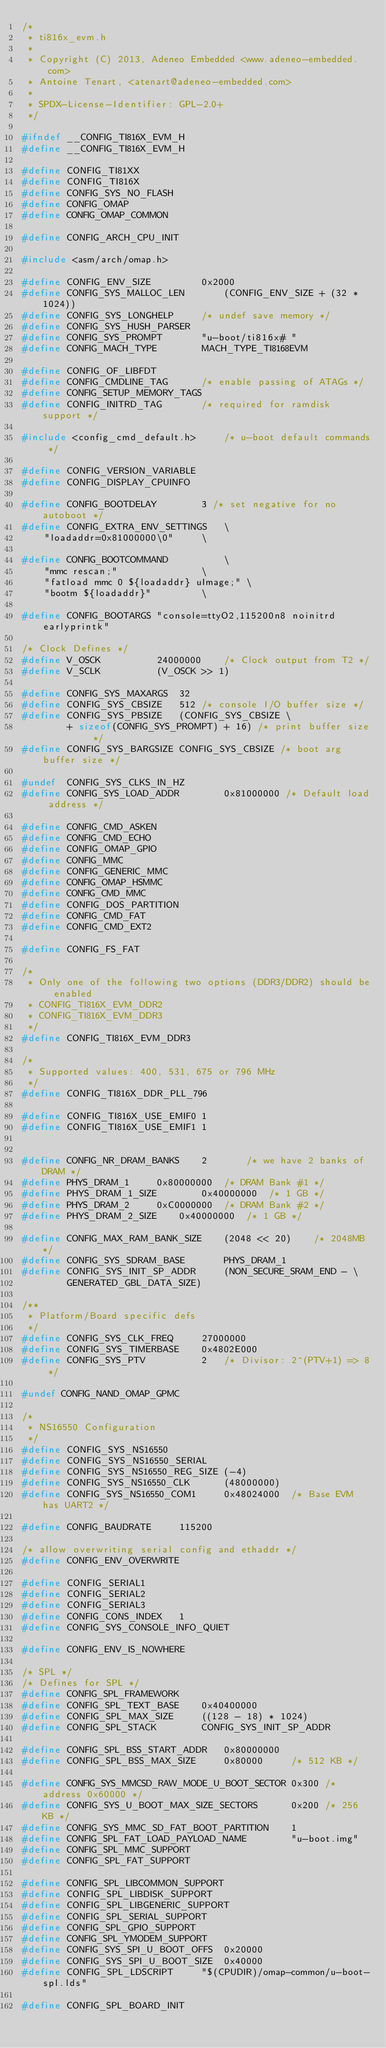Convert code to text. <code><loc_0><loc_0><loc_500><loc_500><_C_>/*
 * ti816x_evm.h
 *
 * Copyright (C) 2013, Adeneo Embedded <www.adeneo-embedded.com>
 * Antoine Tenart, <atenart@adeneo-embedded.com>
 *
 * SPDX-License-Identifier:	GPL-2.0+
 */

#ifndef __CONFIG_TI816X_EVM_H
#define __CONFIG_TI816X_EVM_H

#define CONFIG_TI81XX
#define CONFIG_TI816X
#define CONFIG_SYS_NO_FLASH
#define CONFIG_OMAP
#define CONFIG_OMAP_COMMON

#define CONFIG_ARCH_CPU_INIT

#include <asm/arch/omap.h>

#define CONFIG_ENV_SIZE			0x2000
#define CONFIG_SYS_MALLOC_LEN		(CONFIG_ENV_SIZE + (32 * 1024))
#define CONFIG_SYS_LONGHELP		/* undef save memory */
#define CONFIG_SYS_HUSH_PARSER
#define CONFIG_SYS_PROMPT		"u-boot/ti816x# "
#define CONFIG_MACH_TYPE		MACH_TYPE_TI8168EVM

#define CONFIG_OF_LIBFDT
#define CONFIG_CMDLINE_TAG		/* enable passing of ATAGs */
#define CONFIG_SETUP_MEMORY_TAGS
#define CONFIG_INITRD_TAG		/* required for ramdisk support */

#include <config_cmd_default.h>		/* u-boot default commands */

#define CONFIG_VERSION_VARIABLE
#define CONFIG_DISPLAY_CPUINFO

#define CONFIG_BOOTDELAY		3 /* set negative for no autoboot */
#define CONFIG_EXTRA_ENV_SETTINGS	\
	"loadaddr=0x81000000\0"		\

#define CONFIG_BOOTCOMMAND			\
	"mmc rescan;"				\
	"fatload mmc 0 ${loadaddr} uImage;"	\
	"bootm ${loadaddr}"			\

#define CONFIG_BOOTARGS	"console=ttyO2,115200n8 noinitrd earlyprintk"

/* Clock Defines */
#define V_OSCK          24000000    /* Clock output from T2 */
#define V_SCLK          (V_OSCK >> 1)

#define CONFIG_SYS_MAXARGS	32
#define CONFIG_SYS_CBSIZE	512 /* console I/O buffer size */
#define CONFIG_SYS_PBSIZE	(CONFIG_SYS_CBSIZE \
		+ sizeof(CONFIG_SYS_PROMPT) + 16) /* print buffer size */
#define CONFIG_SYS_BARGSIZE	CONFIG_SYS_CBSIZE /* boot arg buffer size */

#undef  CONFIG_SYS_CLKS_IN_HZ
#define CONFIG_SYS_LOAD_ADDR		0x81000000 /* Default load address */

#define CONFIG_CMD_ASKEN
#define CONFIG_CMD_ECHO
#define CONFIG_OMAP_GPIO
#define CONFIG_MMC
#define CONFIG_GENERIC_MMC
#define CONFIG_OMAP_HSMMC
#define CONFIG_CMD_MMC
#define CONFIG_DOS_PARTITION
#define CONFIG_CMD_FAT
#define CONFIG_CMD_EXT2

#define CONFIG_FS_FAT

/*
 * Only one of the following two options (DDR3/DDR2) should be enabled
 * CONFIG_TI816X_EVM_DDR2
 * CONFIG_TI816X_EVM_DDR3
 */
#define CONFIG_TI816X_EVM_DDR3

/*
 * Supported values: 400, 531, 675 or 796 MHz
 */
#define CONFIG_TI816X_DDR_PLL_796

#define CONFIG_TI816X_USE_EMIF0	1
#define CONFIG_TI816X_USE_EMIF1	1


#define CONFIG_NR_DRAM_BANKS	2		/* we have 2 banks of DRAM */
#define PHYS_DRAM_1		0x80000000	/* DRAM Bank #1 */
#define PHYS_DRAM_1_SIZE        0x40000000	/* 1 GB */
#define PHYS_DRAM_2		0xC0000000	/* DRAM Bank #2 */
#define PHYS_DRAM_2_SIZE	0x40000000	/* 1 GB */

#define CONFIG_MAX_RAM_BANK_SIZE	(2048 << 20)	/* 2048MB */
#define CONFIG_SYS_SDRAM_BASE		PHYS_DRAM_1
#define CONFIG_SYS_INIT_SP_ADDR		(NON_SECURE_SRAM_END - \
		GENERATED_GBL_DATA_SIZE)

/**
 * Platform/Board specific defs
 */
#define CONFIG_SYS_CLK_FREQ     27000000
#define CONFIG_SYS_TIMERBASE    0x4802E000
#define CONFIG_SYS_PTV          2   /* Divisor: 2^(PTV+1) => 8 */

#undef CONFIG_NAND_OMAP_GPMC

/*
 * NS16550 Configuration
 */
#define CONFIG_SYS_NS16550
#define CONFIG_SYS_NS16550_SERIAL
#define CONFIG_SYS_NS16550_REG_SIZE (-4)
#define CONFIG_SYS_NS16550_CLK      (48000000)
#define CONFIG_SYS_NS16550_COM1     0x48024000  /* Base EVM has UART2 */

#define CONFIG_BAUDRATE     115200

/* allow overwriting serial config and ethaddr */
#define CONFIG_ENV_OVERWRITE

#define CONFIG_SERIAL1
#define CONFIG_SERIAL2
#define CONFIG_SERIAL3
#define CONFIG_CONS_INDEX	1
#define CONFIG_SYS_CONSOLE_INFO_QUIET

#define CONFIG_ENV_IS_NOWHERE

/* SPL */
/* Defines for SPL */
#define CONFIG_SPL_FRAMEWORK
#define CONFIG_SPL_TEXT_BASE    0x40400000
#define CONFIG_SPL_MAX_SIZE     ((128 - 18) * 1024)
#define CONFIG_SPL_STACK        CONFIG_SYS_INIT_SP_ADDR

#define CONFIG_SPL_BSS_START_ADDR   0x80000000
#define CONFIG_SPL_BSS_MAX_SIZE     0x80000     /* 512 KB */

#define CONFIG_SYS_MMCSD_RAW_MODE_U_BOOT_SECTOR 0x300 /* address 0x60000 */
#define CONFIG_SYS_U_BOOT_MAX_SIZE_SECTORS      0x200 /* 256 KB */
#define CONFIG_SYS_MMC_SD_FAT_BOOT_PARTITION    1
#define CONFIG_SPL_FAT_LOAD_PAYLOAD_NAME        "u-boot.img"
#define CONFIG_SPL_MMC_SUPPORT
#define CONFIG_SPL_FAT_SUPPORT

#define CONFIG_SPL_LIBCOMMON_SUPPORT
#define CONFIG_SPL_LIBDISK_SUPPORT
#define CONFIG_SPL_LIBGENERIC_SUPPORT
#define CONFIG_SPL_SERIAL_SUPPORT
#define CONFIG_SPL_GPIO_SUPPORT
#define CONFIG_SPL_YMODEM_SUPPORT
#define CONFIG_SYS_SPI_U_BOOT_OFFS  0x20000
#define CONFIG_SYS_SPI_U_BOOT_SIZE  0x40000
#define CONFIG_SPL_LDSCRIPT     "$(CPUDIR)/omap-common/u-boot-spl.lds"

#define CONFIG_SPL_BOARD_INIT
</code> 